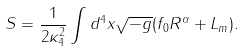<formula> <loc_0><loc_0><loc_500><loc_500>S = \frac { 1 } { 2 \kappa _ { 4 } ^ { 2 } } \int d ^ { 4 } x \sqrt { - g } ( f _ { 0 } R ^ { \alpha } + L _ { m } ) .</formula> 